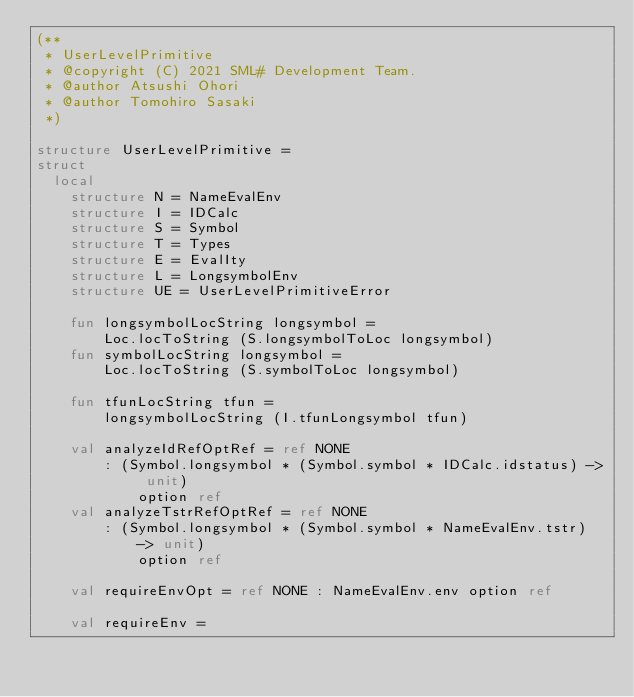Convert code to text. <code><loc_0><loc_0><loc_500><loc_500><_SML_>(**
 * UserLevelPrimitive
 * @copyright (C) 2021 SML# Development Team.
 * @author Atsushi Ohori
 * @author Tomohiro Sasaki
 *)

structure UserLevelPrimitive =
struct
  local
    structure N = NameEvalEnv
    structure I = IDCalc
    structure S = Symbol
    structure T = Types
    structure E = EvalIty
    structure L = LongsymbolEnv
    structure UE = UserLevelPrimitiveError

    fun longsymbolLocString longsymbol =
        Loc.locToString (S.longsymbolToLoc longsymbol)
    fun symbolLocString longsymbol =
        Loc.locToString (S.symbolToLoc longsymbol)

    fun tfunLocString tfun =
        longsymbolLocString (I.tfunLongsymbol tfun)

    val analyzeIdRefOptRef = ref NONE
        : (Symbol.longsymbol * (Symbol.symbol * IDCalc.idstatus) -> unit) 
            option ref
    val analyzeTstrRefOptRef = ref NONE
        : (Symbol.longsymbol * (Symbol.symbol * NameEvalEnv.tstr) -> unit)
            option ref

    val requireEnvOpt = ref NONE : NameEvalEnv.env option ref
 
    val requireEnv = </code> 